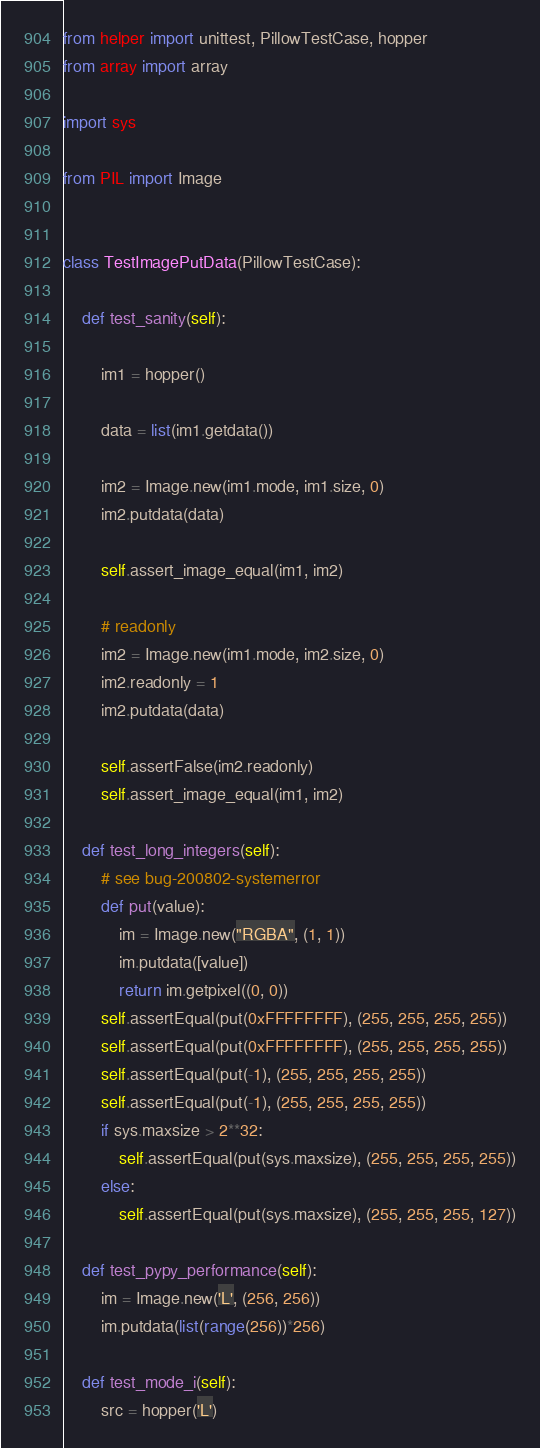Convert code to text. <code><loc_0><loc_0><loc_500><loc_500><_Python_>from helper import unittest, PillowTestCase, hopper
from array import array

import sys

from PIL import Image


class TestImagePutData(PillowTestCase):

    def test_sanity(self):

        im1 = hopper()

        data = list(im1.getdata())

        im2 = Image.new(im1.mode, im1.size, 0)
        im2.putdata(data)

        self.assert_image_equal(im1, im2)

        # readonly
        im2 = Image.new(im1.mode, im2.size, 0)
        im2.readonly = 1
        im2.putdata(data)

        self.assertFalse(im2.readonly)
        self.assert_image_equal(im1, im2)

    def test_long_integers(self):
        # see bug-200802-systemerror
        def put(value):
            im = Image.new("RGBA", (1, 1))
            im.putdata([value])
            return im.getpixel((0, 0))
        self.assertEqual(put(0xFFFFFFFF), (255, 255, 255, 255))
        self.assertEqual(put(0xFFFFFFFF), (255, 255, 255, 255))
        self.assertEqual(put(-1), (255, 255, 255, 255))
        self.assertEqual(put(-1), (255, 255, 255, 255))
        if sys.maxsize > 2**32:
            self.assertEqual(put(sys.maxsize), (255, 255, 255, 255))
        else:
            self.assertEqual(put(sys.maxsize), (255, 255, 255, 127))

    def test_pypy_performance(self):
        im = Image.new('L', (256, 256))
        im.putdata(list(range(256))*256)

    def test_mode_i(self):
        src = hopper('L')</code> 